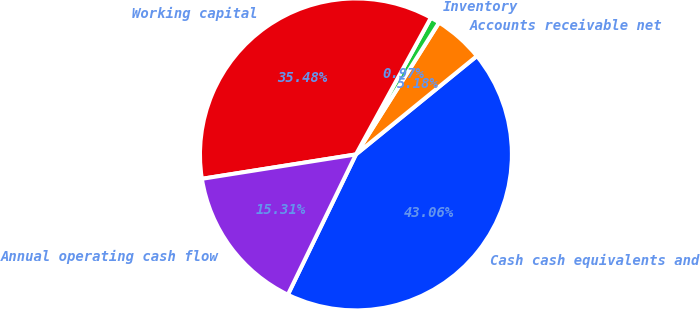Convert chart to OTSL. <chart><loc_0><loc_0><loc_500><loc_500><pie_chart><fcel>Cash cash equivalents and<fcel>Accounts receivable net<fcel>Inventory<fcel>Working capital<fcel>Annual operating cash flow<nl><fcel>43.06%<fcel>5.18%<fcel>0.97%<fcel>35.48%<fcel>15.31%<nl></chart> 